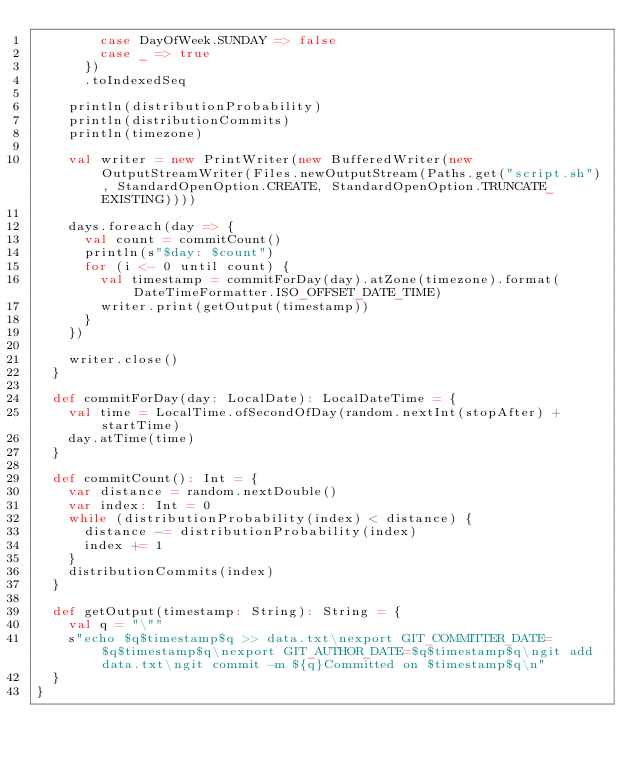Convert code to text. <code><loc_0><loc_0><loc_500><loc_500><_Scala_>        case DayOfWeek.SUNDAY => false
        case _ => true
      })
      .toIndexedSeq

    println(distributionProbability)
    println(distributionCommits)
    println(timezone)

    val writer = new PrintWriter(new BufferedWriter(new OutputStreamWriter(Files.newOutputStream(Paths.get("script.sh"), StandardOpenOption.CREATE, StandardOpenOption.TRUNCATE_EXISTING))))

    days.foreach(day => {
      val count = commitCount()
      println(s"$day: $count")
      for (i <- 0 until count) {
        val timestamp = commitForDay(day).atZone(timezone).format(DateTimeFormatter.ISO_OFFSET_DATE_TIME)
        writer.print(getOutput(timestamp))
      }
    })

    writer.close()
  }

  def commitForDay(day: LocalDate): LocalDateTime = {
    val time = LocalTime.ofSecondOfDay(random.nextInt(stopAfter) + startTime)
    day.atTime(time)
  }

  def commitCount(): Int = {
    var distance = random.nextDouble()
    var index: Int = 0
    while (distributionProbability(index) < distance) {
      distance -= distributionProbability(index)
      index += 1
    }
    distributionCommits(index)
  }

  def getOutput(timestamp: String): String = {
    val q = "\""
    s"echo $q$timestamp$q >> data.txt\nexport GIT_COMMITTER_DATE=$q$timestamp$q\nexport GIT_AUTHOR_DATE=$q$timestamp$q\ngit add data.txt\ngit commit -m ${q}Committed on $timestamp$q\n"
  }
}
</code> 